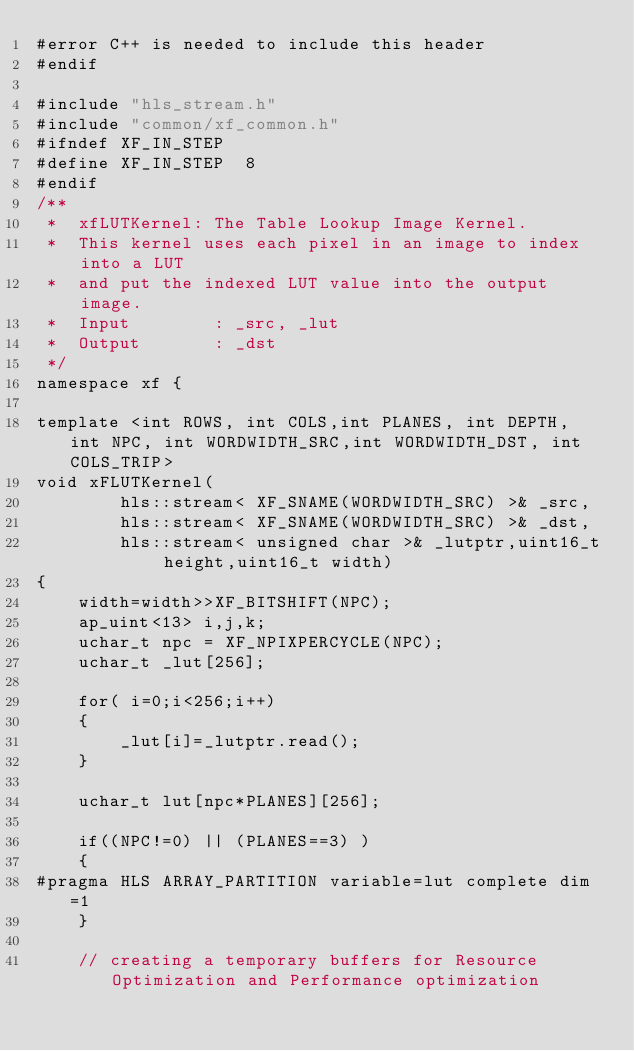<code> <loc_0><loc_0><loc_500><loc_500><_C++_>#error C++ is needed to include this header
#endif

#include "hls_stream.h"
#include "common/xf_common.h"
#ifndef XF_IN_STEP
#define XF_IN_STEP  8
#endif
/**
 *  xfLUTKernel: The Table Lookup Image Kernel.
 *  This kernel uses each pixel in an image to index into a LUT
 *  and put the indexed LUT value into the output image.
 *	Input		 : _src, _lut
 *	Output		 : _dst
 */
namespace xf {

template <int ROWS, int COLS,int PLANES, int DEPTH, int NPC, int WORDWIDTH_SRC,int WORDWIDTH_DST, int COLS_TRIP>
void xFLUTKernel(
		hls::stream< XF_SNAME(WORDWIDTH_SRC) >& _src,
		hls::stream< XF_SNAME(WORDWIDTH_SRC) >& _dst,
		hls::stream< unsigned char >& _lutptr,uint16_t height,uint16_t width)
{
	width=width>>XF_BITSHIFT(NPC);
    ap_uint<13> i,j,k;
    uchar_t npc = XF_NPIXPERCYCLE(NPC);
	uchar_t _lut[256];

	for( i=0;i<256;i++)
	{
		_lut[i]=_lutptr.read();
	}

	uchar_t lut[npc*PLANES][256];

	if((NPC!=0) || (PLANES==3) )
	{
#pragma HLS ARRAY_PARTITION variable=lut complete dim=1
	}

	// creating a temporary buffers for Resource Optimization and Performance optimization</code> 